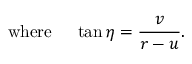Convert formula to latex. <formula><loc_0><loc_0><loc_500><loc_500>w h e r e \quad \tan \eta = { \frac { v } { r - u } } .</formula> 